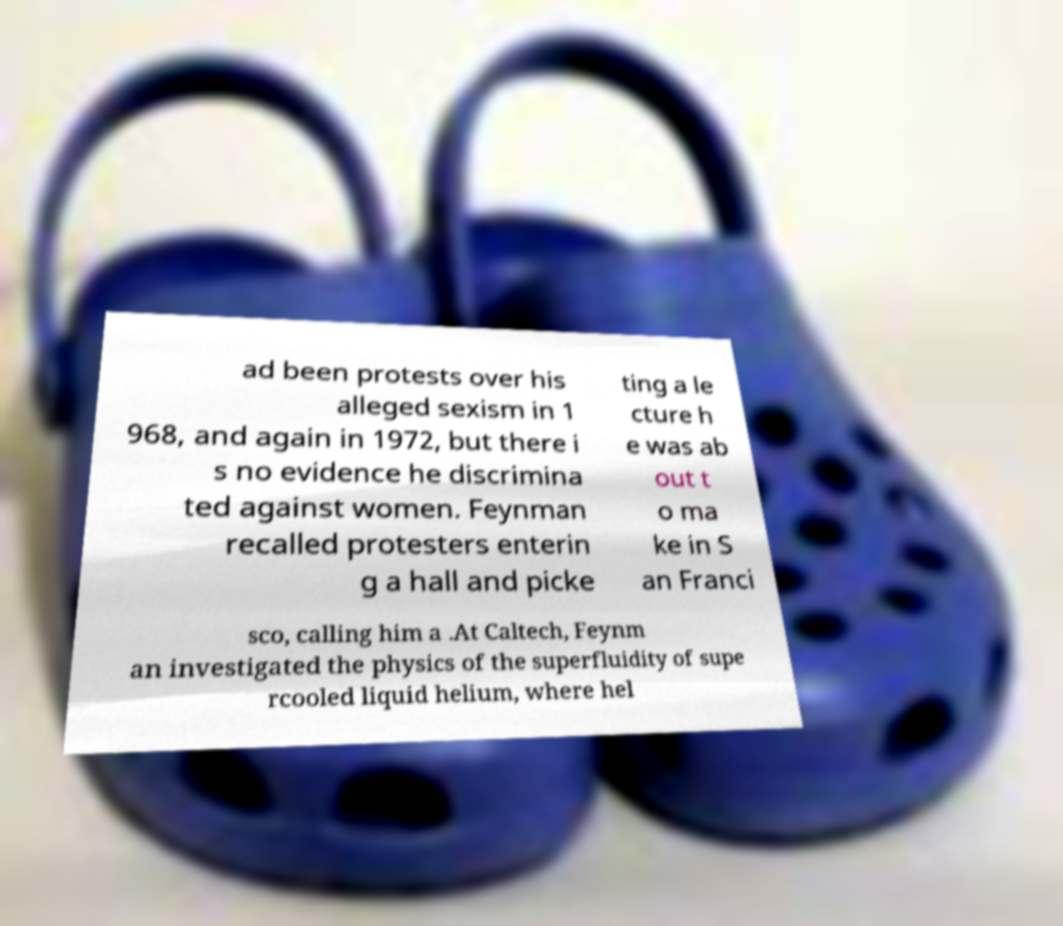Please read and relay the text visible in this image. What does it say? ad been protests over his alleged sexism in 1 968, and again in 1972, but there i s no evidence he discrimina ted against women. Feynman recalled protesters enterin g a hall and picke ting a le cture h e was ab out t o ma ke in S an Franci sco, calling him a .At Caltech, Feynm an investigated the physics of the superfluidity of supe rcooled liquid helium, where hel 